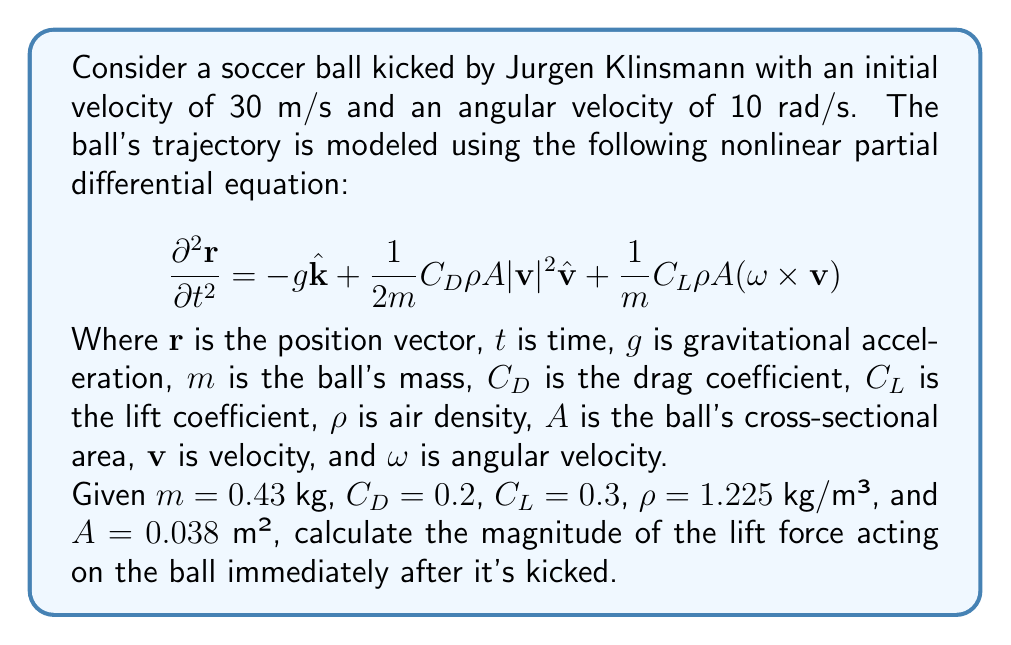Give your solution to this math problem. To solve this problem, we'll focus on the lift force term in the equation and follow these steps:

1) The lift force is given by the term: $\frac{1}{m}C_L\rho A (\mathbf{\omega} \times \mathbf{v})$

2) We need to calculate $\mathbf{\omega} \times \mathbf{v}$. Given:
   - $|\mathbf{\omega}| = 10$ rad/s
   - $|\mathbf{v}| = 30$ m/s
   - Assume $\mathbf{\omega}$ is perpendicular to $\mathbf{v}$ for maximum effect

3) The magnitude of $\mathbf{\omega} \times \mathbf{v}$ is:
   $|\mathbf{\omega} \times \mathbf{v}| = |\mathbf{\omega}||\mathbf{v}|\sin\theta = 10 \cdot 30 \cdot 1 = 300$ m²/s²

4) Now, let's substitute the values into the lift force term:
   $F_L = C_L\rho A |\mathbf{\omega} \times \mathbf{v}|$
   
5) Plugging in the values:
   $F_L = 0.3 \cdot 1.225 \text{ kg/m³} \cdot 0.038 \text{ m²} \cdot 300 \text{ m²/s²}$

6) Calculate:
   $F_L = 4.19955$ N

7) Rounding to three significant figures:
   $F_L \approx 4.20$ N
Answer: 4.20 N 